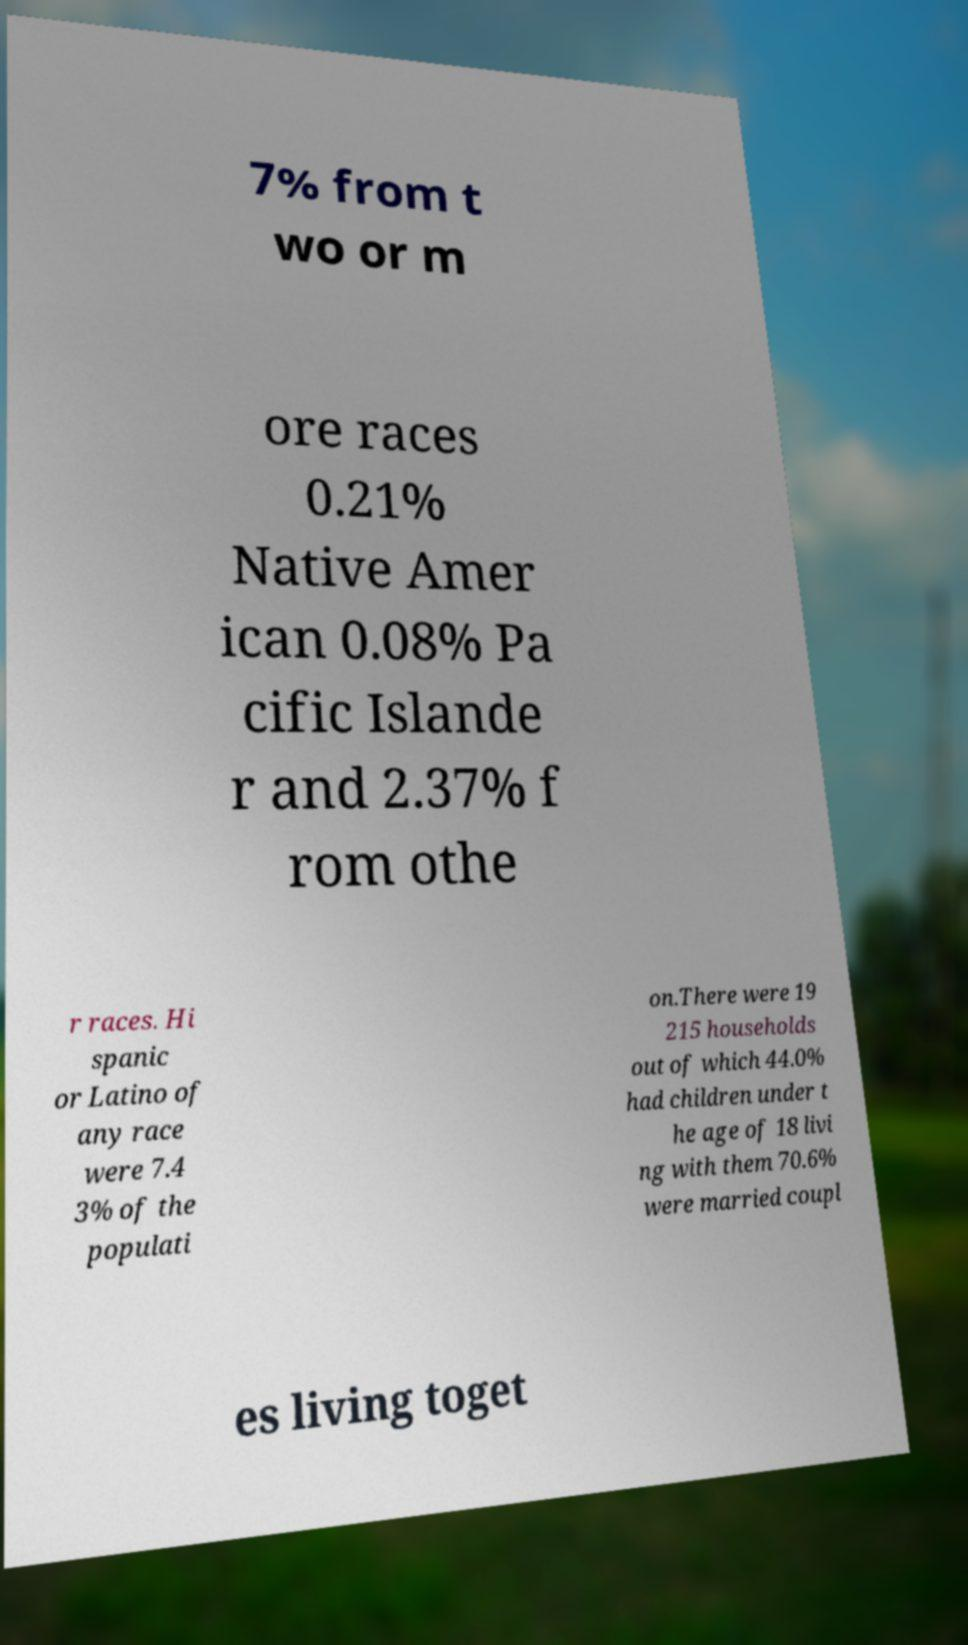I need the written content from this picture converted into text. Can you do that? 7% from t wo or m ore races 0.21% Native Amer ican 0.08% Pa cific Islande r and 2.37% f rom othe r races. Hi spanic or Latino of any race were 7.4 3% of the populati on.There were 19 215 households out of which 44.0% had children under t he age of 18 livi ng with them 70.6% were married coupl es living toget 